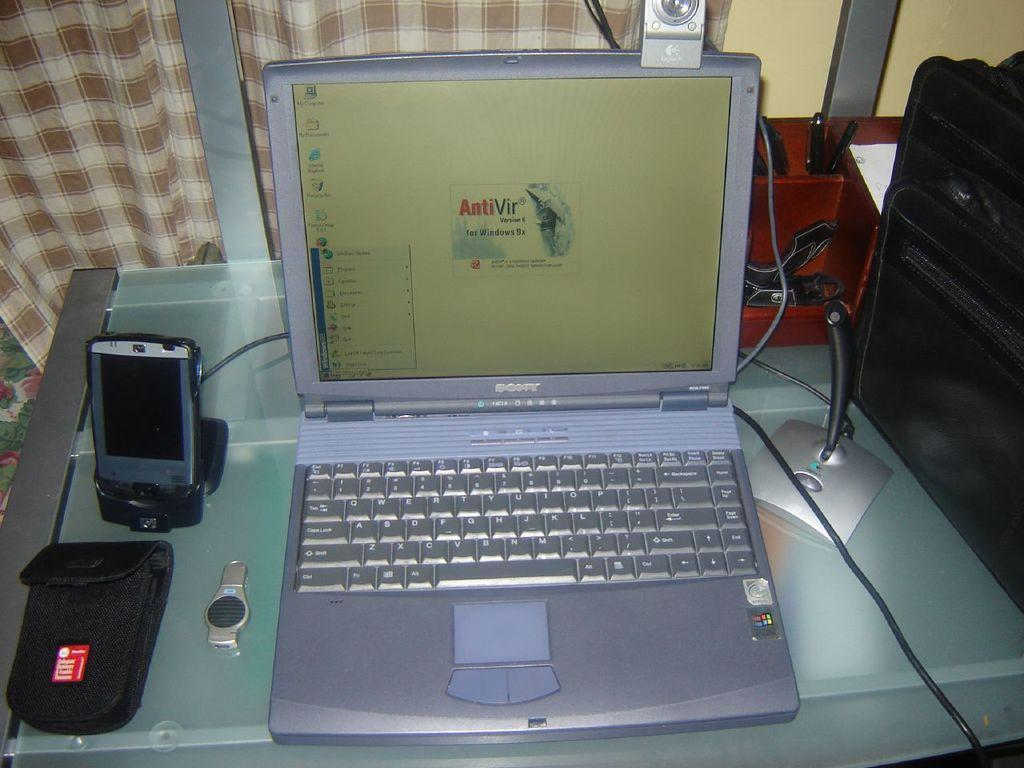<image>
Write a terse but informative summary of the picture. A laptop sits open with it's anti virus software open. 